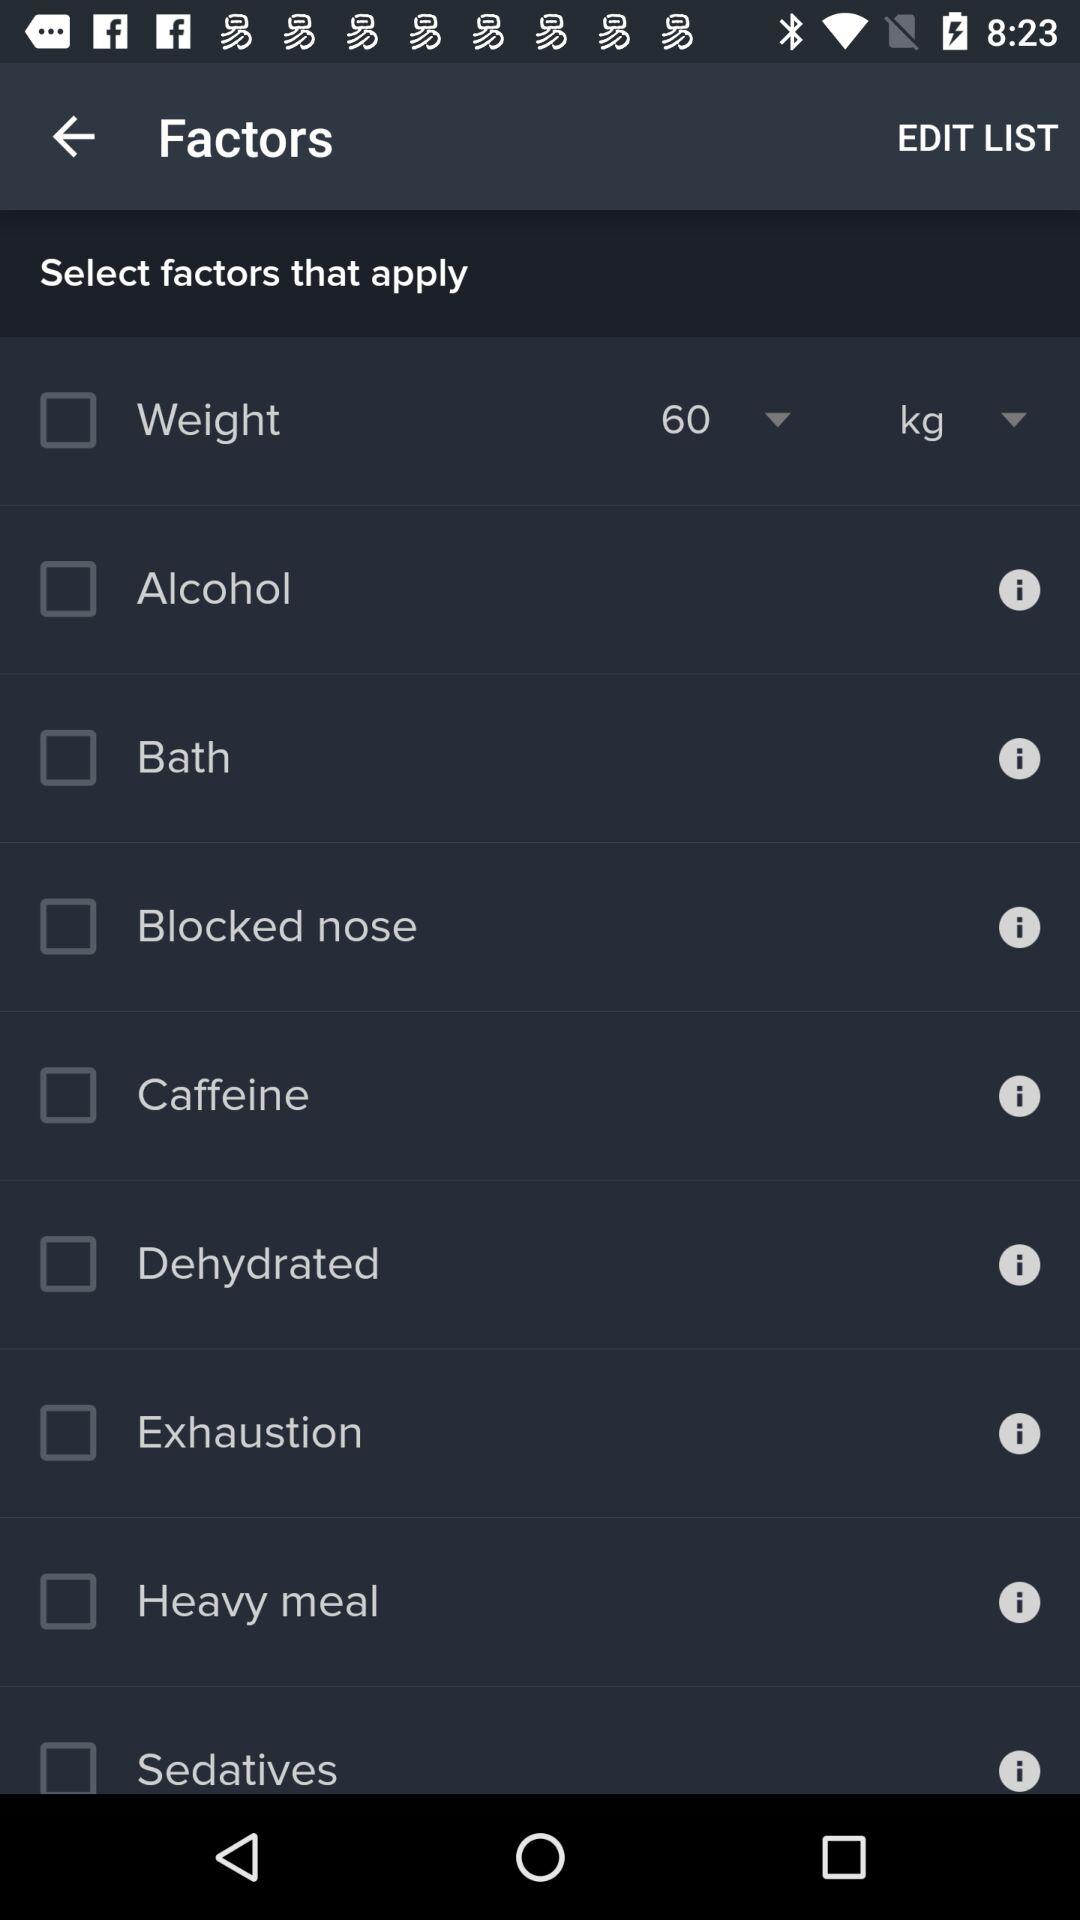What is the selected weight in kilograms? The selected weight in kilograms is 60. 